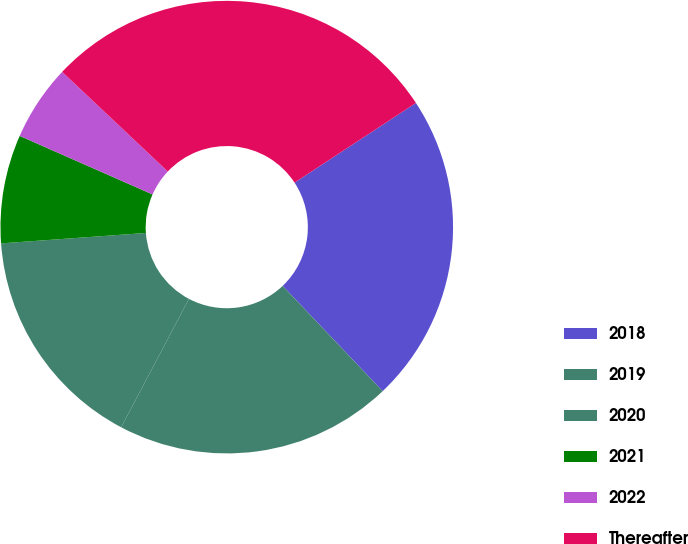Convert chart. <chart><loc_0><loc_0><loc_500><loc_500><pie_chart><fcel>2018<fcel>2019<fcel>2020<fcel>2021<fcel>2022<fcel>Thereafter<nl><fcel>22.15%<fcel>19.82%<fcel>16.13%<fcel>7.75%<fcel>5.43%<fcel>28.72%<nl></chart> 